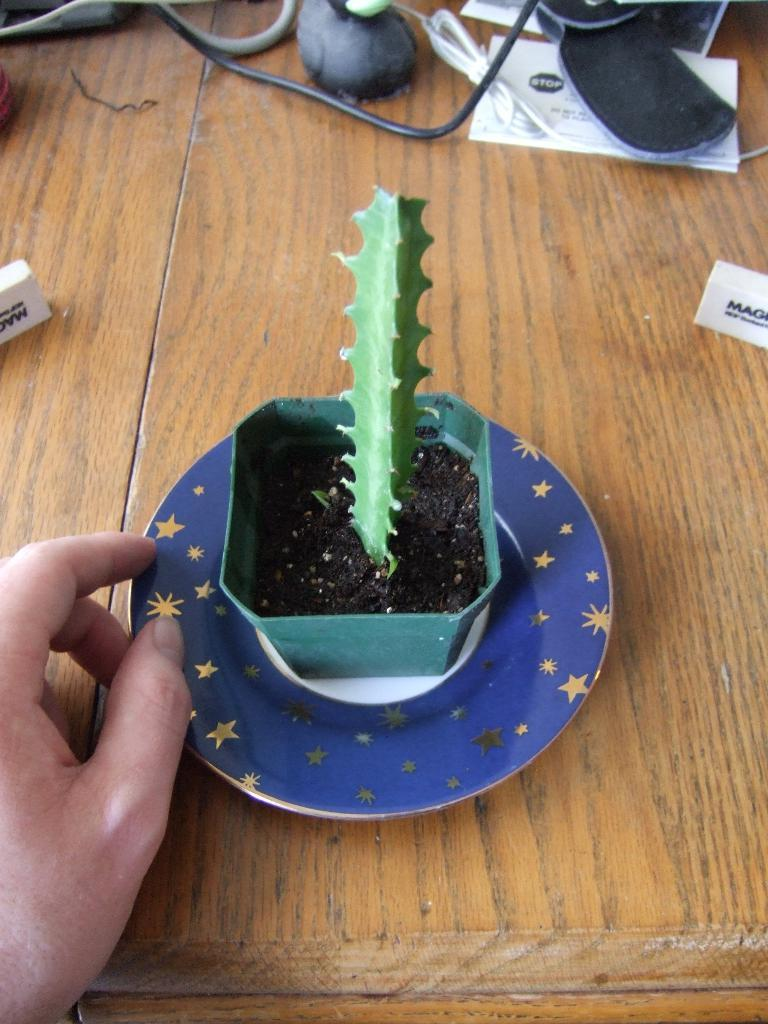What type of living organism can be seen in the image? There is a plant in the image. Where is the person's hand located in the image? The person's hand is on the left side of the image. What can be found on the table in the image? There are objects on a table in the image. What type of bean is being selected by the person in the image? There is no bean present in the image, and the person's hand is not shown selecting anything. 